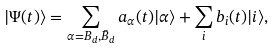Convert formula to latex. <formula><loc_0><loc_0><loc_500><loc_500>| \Psi ( t ) \rangle = \sum _ { \alpha = B _ { d } , \bar { B } _ { d } } a _ { \alpha } ( t ) | \alpha \rangle + \sum _ { i } b _ { i } ( t ) | i \rangle ,</formula> 